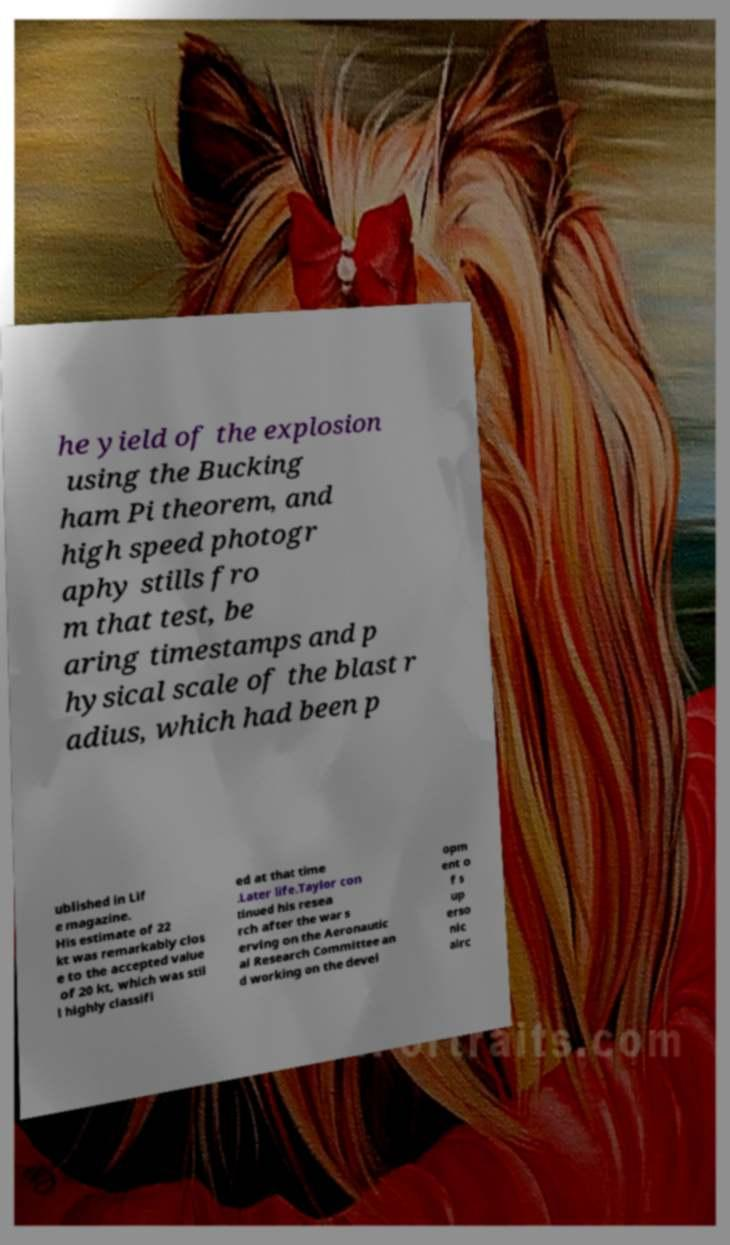For documentation purposes, I need the text within this image transcribed. Could you provide that? he yield of the explosion using the Bucking ham Pi theorem, and high speed photogr aphy stills fro m that test, be aring timestamps and p hysical scale of the blast r adius, which had been p ublished in Lif e magazine. His estimate of 22 kt was remarkably clos e to the accepted value of 20 kt, which was stil l highly classifi ed at that time .Later life.Taylor con tinued his resea rch after the war s erving on the Aeronautic al Research Committee an d working on the devel opm ent o f s up erso nic airc 